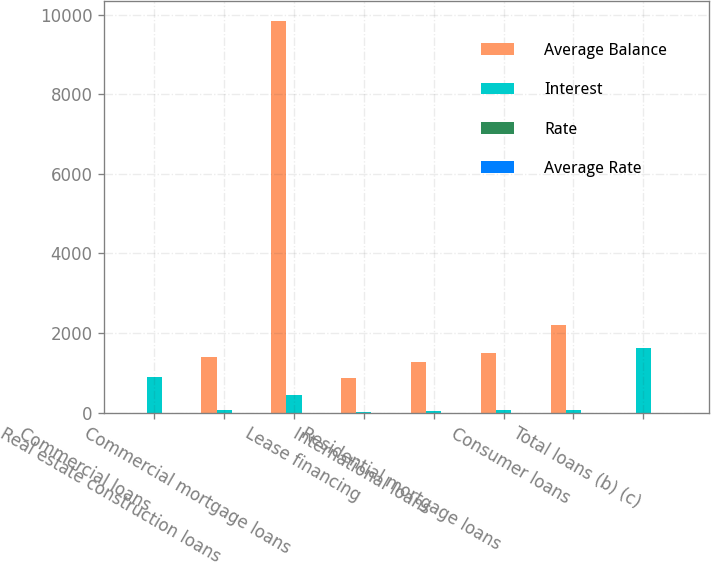Convert chart to OTSL. <chart><loc_0><loc_0><loc_500><loc_500><stacked_bar_chart><ecel><fcel>Commercial loans<fcel>Real estate construction loans<fcel>Commercial mortgage loans<fcel>Lease financing<fcel>International loans<fcel>Residential mortgage loans<fcel>Consumer loans<fcel>Total loans (b) (c)<nl><fcel>Average Balance<fcel>4.925<fcel>1390<fcel>9842<fcel>864<fcel>1272<fcel>1505<fcel>2209<fcel>4.925<nl><fcel>Interest<fcel>903<fcel>62<fcel>437<fcel>26<fcel>47<fcel>68<fcel>76<fcel>1619<nl><fcel>Rate<fcel>3.44<fcel>4.44<fcel>4.44<fcel>3.01<fcel>3.73<fcel>4.55<fcel>3.42<fcel>3.74<nl><fcel>Average Rate<fcel>3.89<fcel>3.17<fcel>4.1<fcel>3.88<fcel>3.94<fcel>5.3<fcel>3.54<fcel>4<nl></chart> 